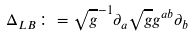<formula> <loc_0><loc_0><loc_500><loc_500>\Delta _ { L B } \colon = \sqrt { g } ^ { - 1 } \partial _ { a } \sqrt { g } g ^ { a b } \partial _ { b }</formula> 